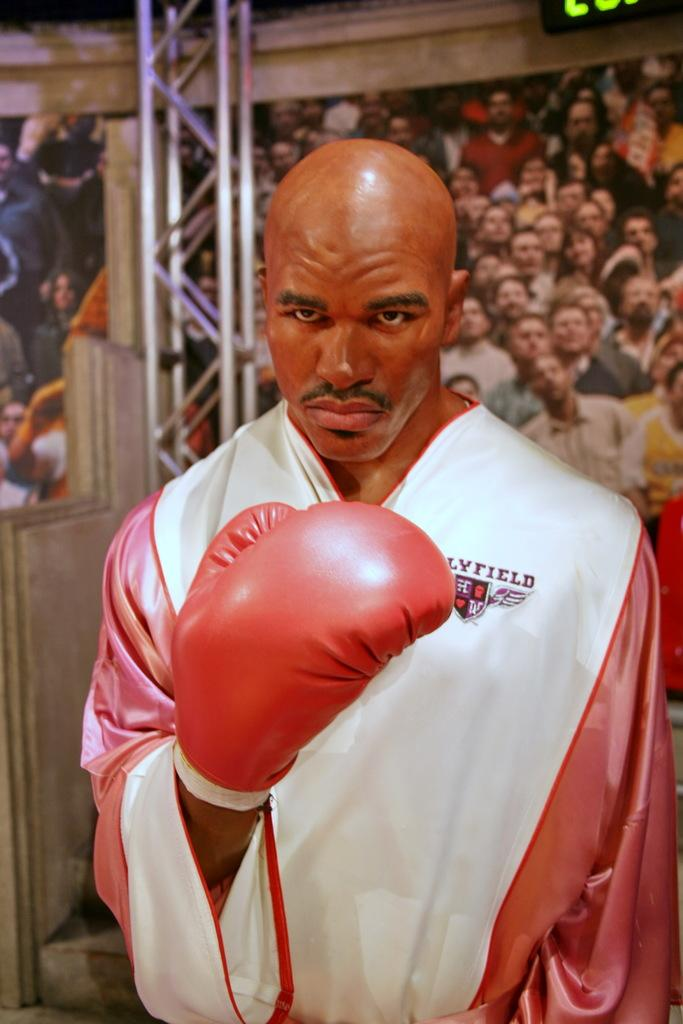Who is the main subject in the image? There is a man in the image. What is the man wearing on his hands? The man is wearing hand gloves. What can be seen in the background of the image? There are many people in the background of the image. What objects are visible in the image besides the man? There are rods visible in the image. Where is the display screen located in the image? There is a display screen in the top left corner of the image. How much hate is being expressed by the oven in the image? There is no oven present in the image, so it is not possible to determine the amount of hate being expressed. 